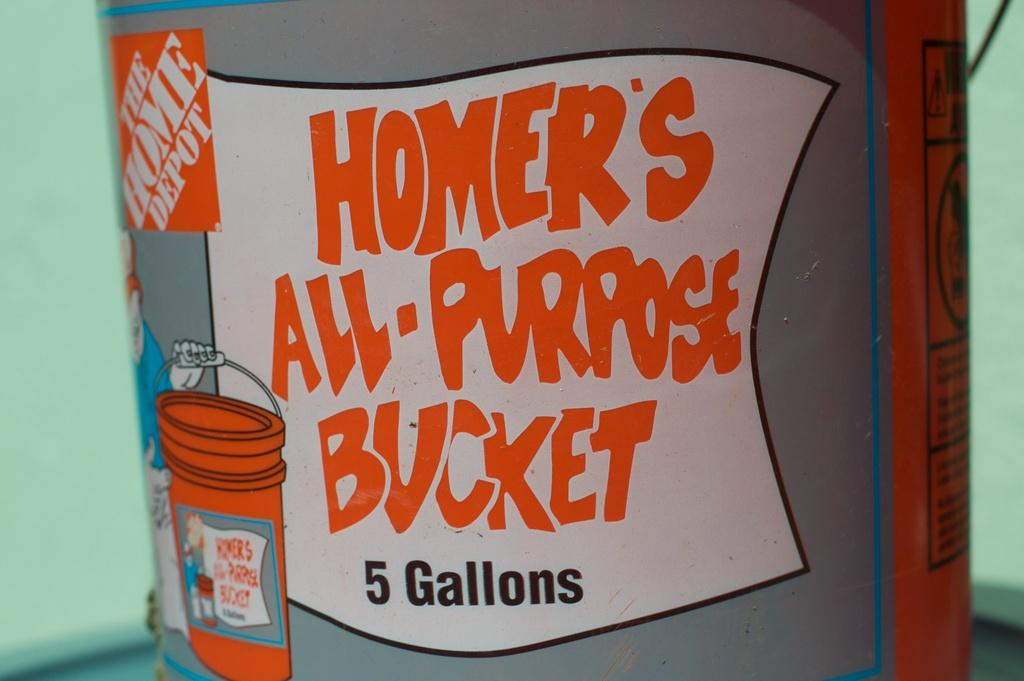Provide a one-sentence caption for the provided image. A cartoon label covers a 5 gallon bucket. 